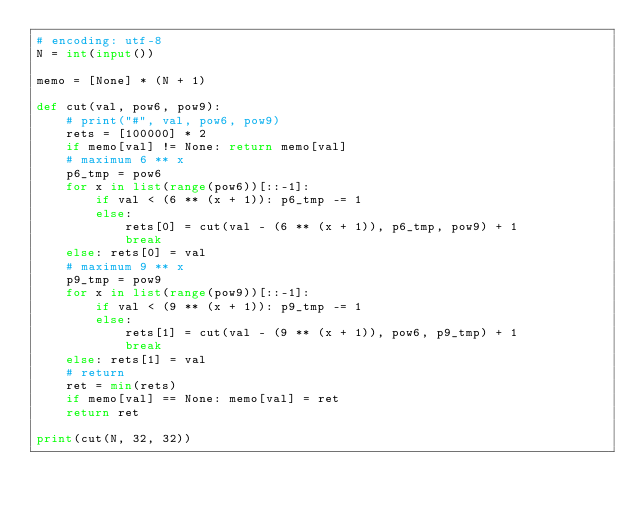<code> <loc_0><loc_0><loc_500><loc_500><_Python_># encoding: utf-8
N = int(input())

memo = [None] * (N + 1)

def cut(val, pow6, pow9):
    # print("#", val, pow6, pow9)
    rets = [100000] * 2
    if memo[val] != None: return memo[val]
    # maximum 6 ** x
    p6_tmp = pow6
    for x in list(range(pow6))[::-1]:
        if val < (6 ** (x + 1)): p6_tmp -= 1
        else:
            rets[0] = cut(val - (6 ** (x + 1)), p6_tmp, pow9) + 1
            break
    else: rets[0] = val
    # maximum 9 ** x
    p9_tmp = pow9
    for x in list(range(pow9))[::-1]:
        if val < (9 ** (x + 1)): p9_tmp -= 1
        else:
            rets[1] = cut(val - (9 ** (x + 1)), pow6, p9_tmp) + 1
            break
    else: rets[1] = val
    # return
    ret = min(rets)
    if memo[val] == None: memo[val] = ret
    return ret

print(cut(N, 32, 32))</code> 